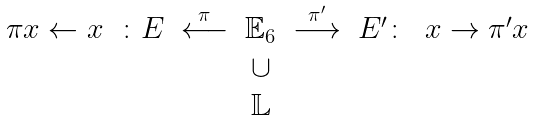Convert formula to latex. <formula><loc_0><loc_0><loc_500><loc_500>\begin{array} { c c c c c c c } \pi x \leftarrow x & \colon E & \stackrel { \pi } \longleftarrow & \mathbb { E } _ { 6 } & \stackrel { \pi ^ { \prime } } \longrightarrow & E ^ { \prime } \colon & x \rightarrow \pi ^ { \prime } x \\ & & & \cup & & & \\ & & & \mathbb { L } & & & \end{array}</formula> 